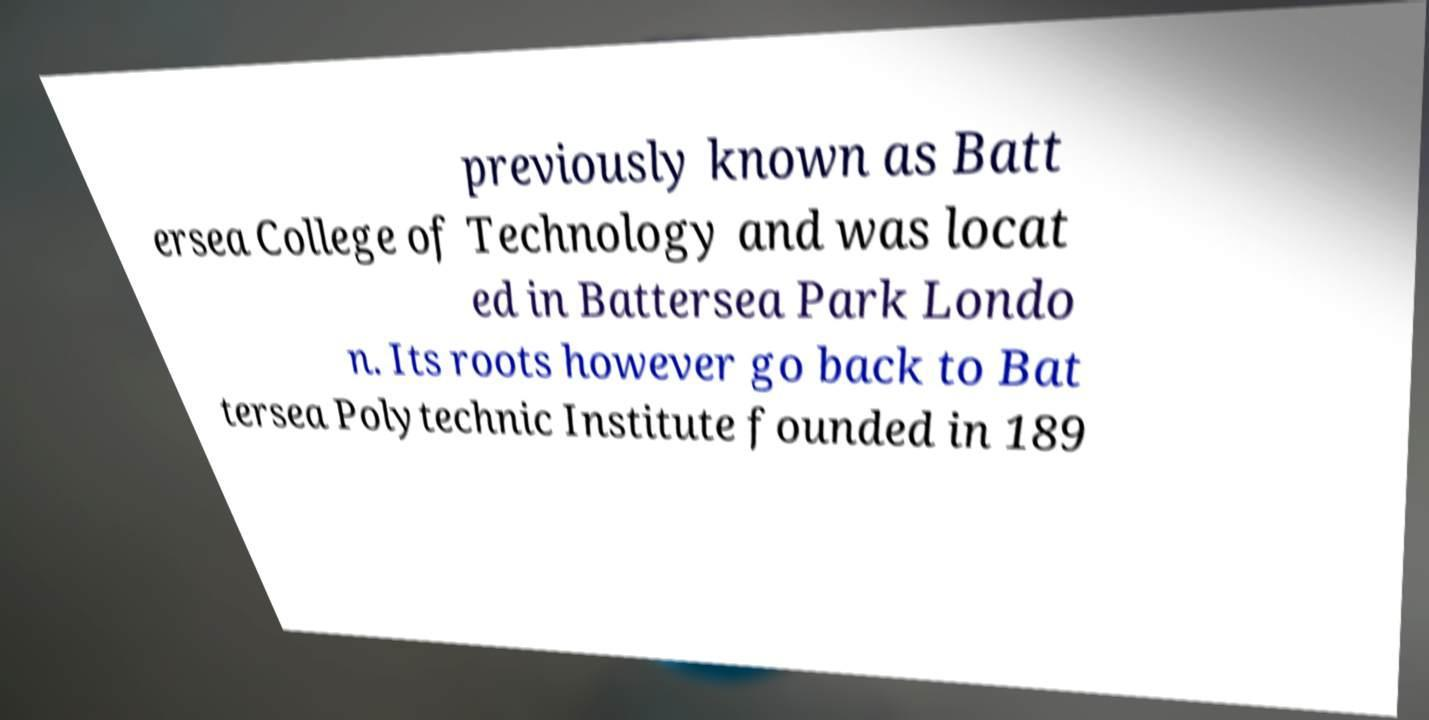Please identify and transcribe the text found in this image. previously known as Batt ersea College of Technology and was locat ed in Battersea Park Londo n. Its roots however go back to Bat tersea Polytechnic Institute founded in 189 